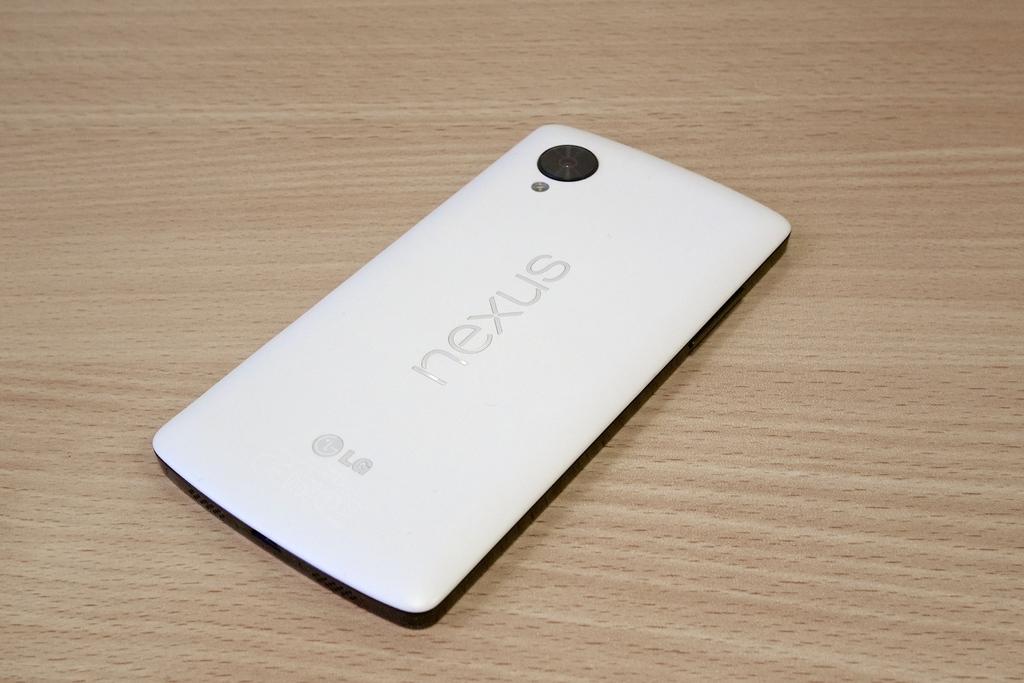Is the phone a nexus?
Your response must be concise. Yes. What brand is this phone?
Make the answer very short. Lg. 